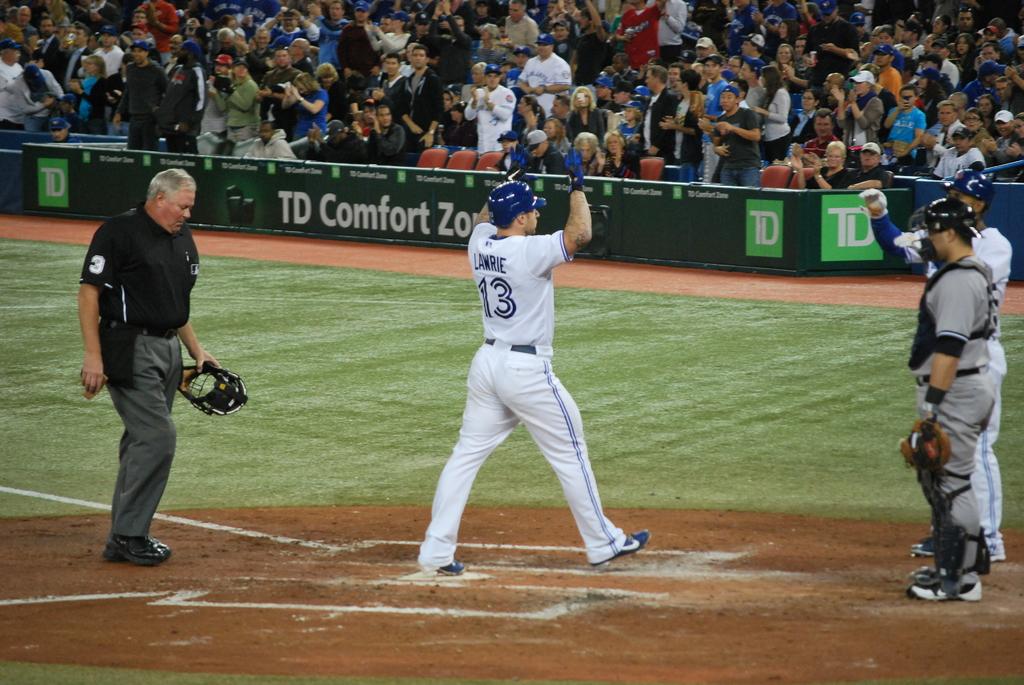What number has just scored a run?
Offer a terse response. 13. 